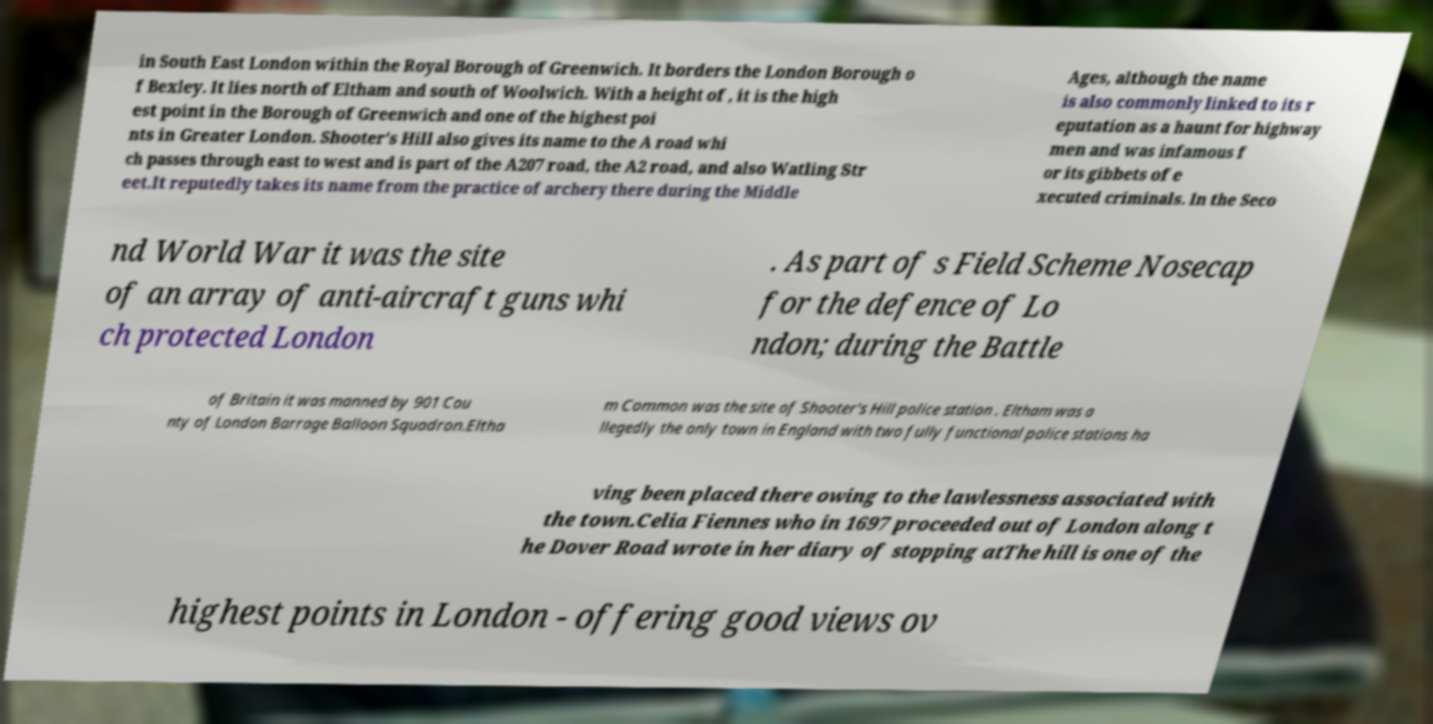Can you accurately transcribe the text from the provided image for me? in South East London within the Royal Borough of Greenwich. It borders the London Borough o f Bexley. It lies north of Eltham and south of Woolwich. With a height of , it is the high est point in the Borough of Greenwich and one of the highest poi nts in Greater London. Shooter's Hill also gives its name to the A road whi ch passes through east to west and is part of the A207 road, the A2 road, and also Watling Str eet.It reputedly takes its name from the practice of archery there during the Middle Ages, although the name is also commonly linked to its r eputation as a haunt for highway men and was infamous f or its gibbets of e xecuted criminals. In the Seco nd World War it was the site of an array of anti-aircraft guns whi ch protected London . As part of s Field Scheme Nosecap for the defence of Lo ndon; during the Battle of Britain it was manned by 901 Cou nty of London Barrage Balloon Squadron.Eltha m Common was the site of Shooter's Hill police station . Eltham was a llegedly the only town in England with two fully functional police stations ha ving been placed there owing to the lawlessness associated with the town.Celia Fiennes who in 1697 proceeded out of London along t he Dover Road wrote in her diary of stopping atThe hill is one of the highest points in London - offering good views ov 